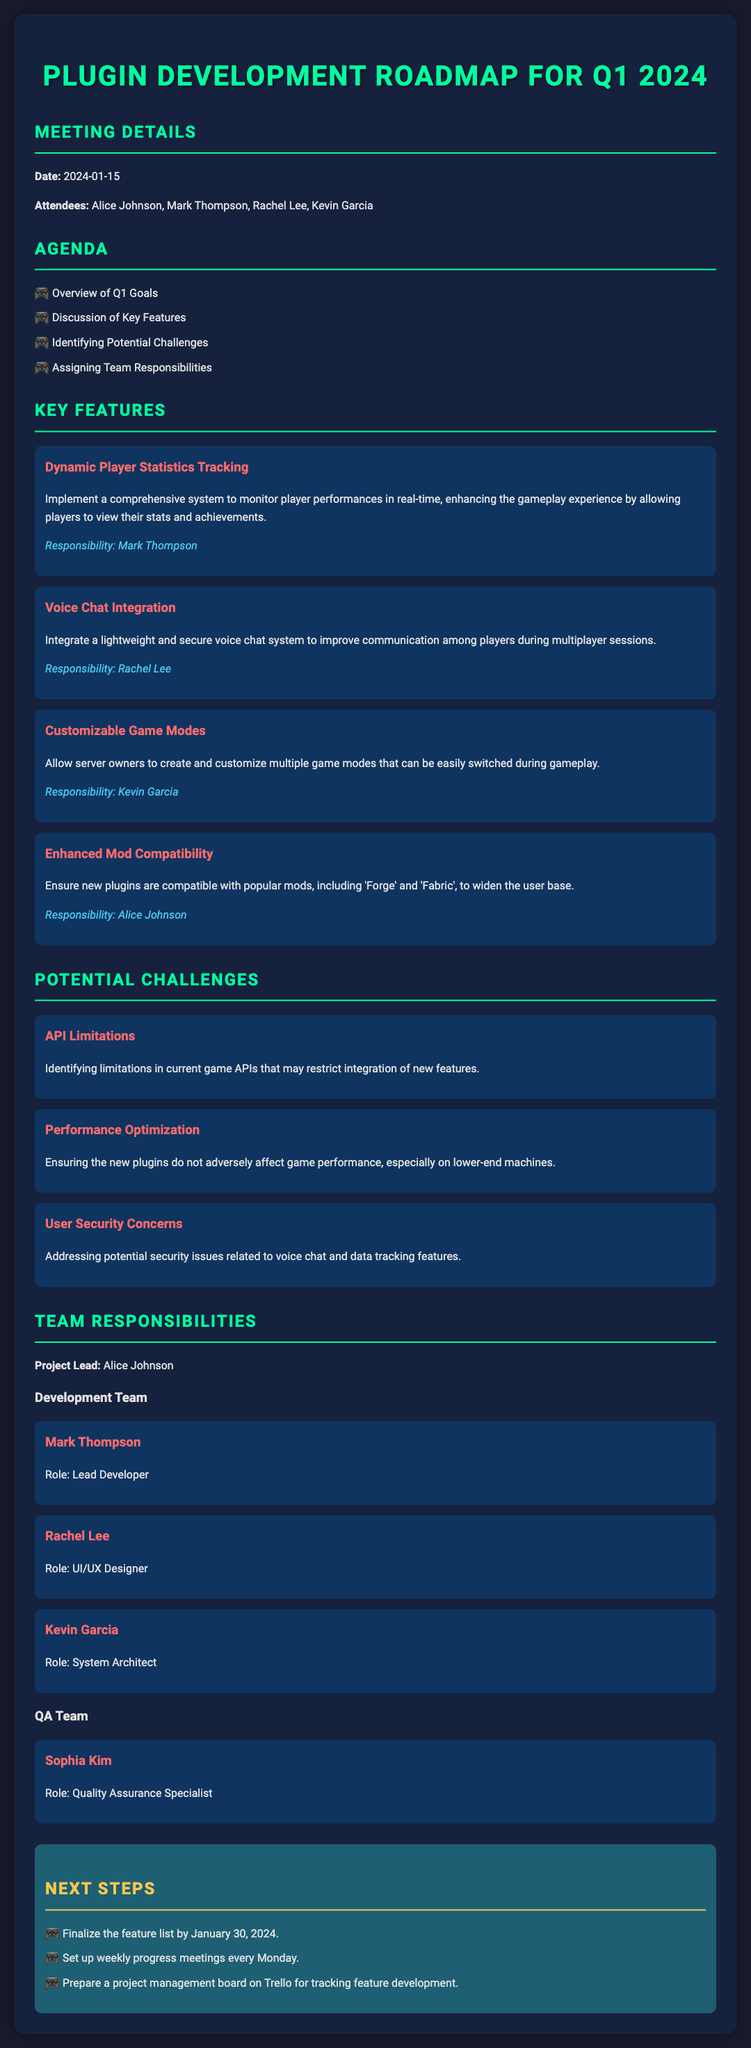What is the date of the meeting? The date of the meeting is explicitly mentioned in the document as "2024-01-15."
Answer: 2024-01-15 Who is responsible for Dynamic Player Statistics Tracking? The responsibility for Dynamic Player Statistics Tracking is assigned to Mark Thompson, as stated in the document.
Answer: Mark Thompson What is one of the potential challenges mentioned? One of the potential challenges identified in the document is "API Limitations."
Answer: API Limitations Who is the Project Lead? The document specifies that the Project Lead is Alice Johnson.
Answer: Alice Johnson What feature allows server owners to customize game modes? The feature that allows server owners to customize game modes is "Customizable Game Modes," explicitly outlined in the document.
Answer: Customizable Game Modes What is the role of Rachel Lee? Rachel Lee's role is clearly defined in the document as a UI/UX Designer.
Answer: UI/UX Designer How many steps are listed under Next Steps? The document lists a total of three steps under the section "Next Steps."
Answer: Three What color is used for the meeting title? The meeting title is styled in a bright green color, specifically indicated as #00ff9f in the document.
Answer: #00ff9f Which team member is responsible for voice chat integration? The document assigns Rachel Lee for the responsibility of integrating the voice chat system.
Answer: Rachel Lee 